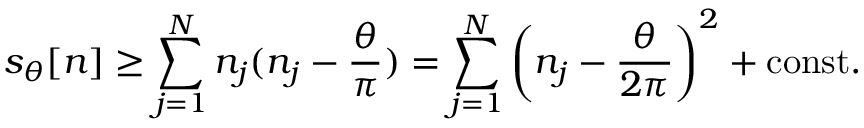Convert formula to latex. <formula><loc_0><loc_0><loc_500><loc_500>s _ { \theta } [ n ] \geq \sum _ { j = 1 } ^ { N } n _ { j } ( n _ { j } - \frac { \theta } { \pi } ) = \sum _ { j = 1 } ^ { N } \left ( n _ { j } - \frac { \theta } { 2 \pi } \right ) ^ { 2 } + c o n s t .</formula> 